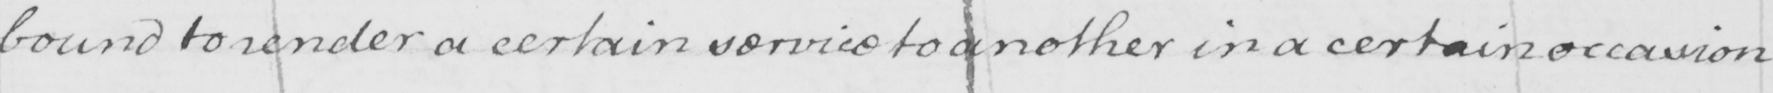Please provide the text content of this handwritten line. bound to render a certain service to another in a certain occasion 